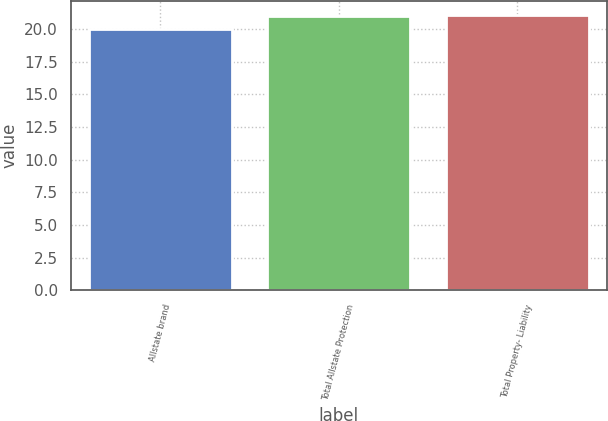Convert chart to OTSL. <chart><loc_0><loc_0><loc_500><loc_500><bar_chart><fcel>Allstate brand<fcel>Total Allstate Protection<fcel>Total Property- Liability<nl><fcel>20<fcel>21<fcel>21.1<nl></chart> 